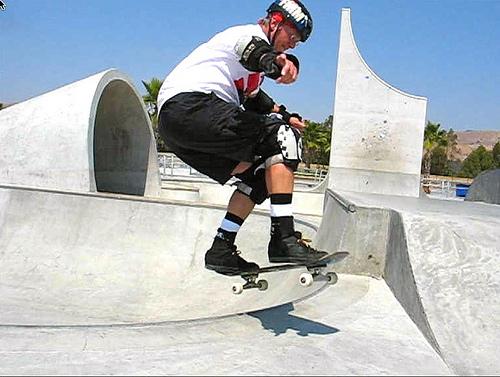Is this a sunny day?
Be succinct. Yes. What is the man skating on?
Concise answer only. Skateboard. Is the skateboarder wearing safety gear?
Be succinct. Yes. 